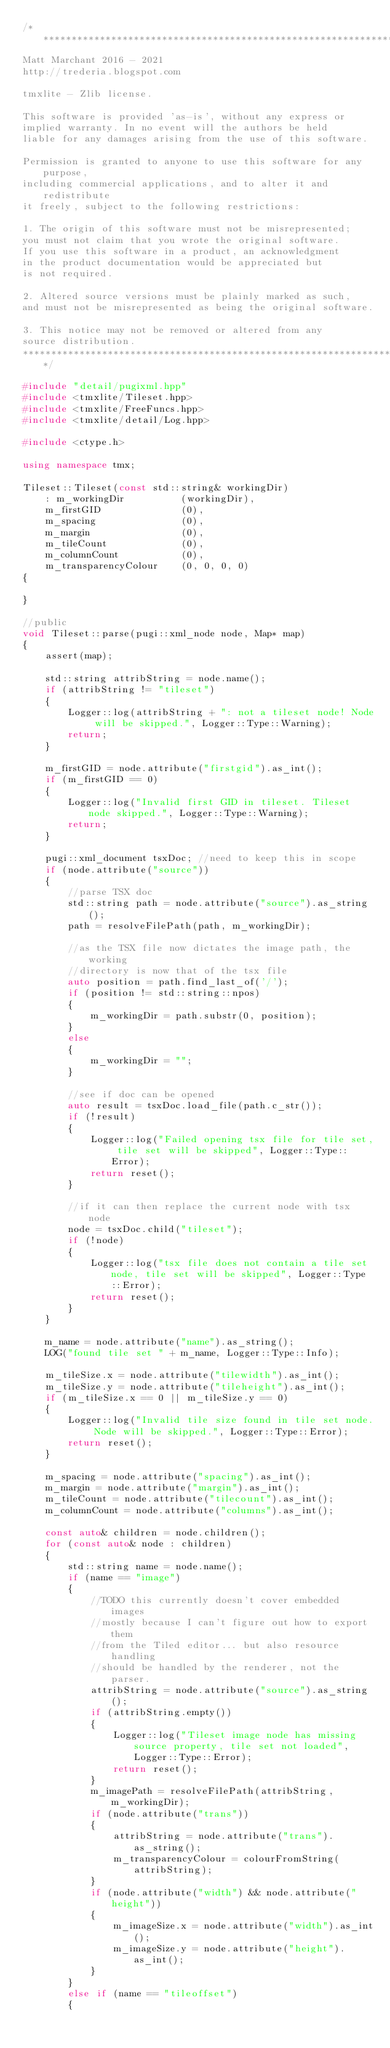Convert code to text. <code><loc_0><loc_0><loc_500><loc_500><_C++_>/*********************************************************************
Matt Marchant 2016 - 2021
http://trederia.blogspot.com

tmxlite - Zlib license.

This software is provided 'as-is', without any express or
implied warranty. In no event will the authors be held
liable for any damages arising from the use of this software.

Permission is granted to anyone to use this software for any purpose,
including commercial applications, and to alter it and redistribute
it freely, subject to the following restrictions:

1. The origin of this software must not be misrepresented;
you must not claim that you wrote the original software.
If you use this software in a product, an acknowledgment
in the product documentation would be appreciated but
is not required.

2. Altered source versions must be plainly marked as such,
and must not be misrepresented as being the original software.

3. This notice may not be removed or altered from any
source distribution.
*********************************************************************/

#include "detail/pugixml.hpp"
#include <tmxlite/Tileset.hpp>
#include <tmxlite/FreeFuncs.hpp>
#include <tmxlite/detail/Log.hpp>

#include <ctype.h>

using namespace tmx;

Tileset::Tileset(const std::string& workingDir)
    : m_workingDir          (workingDir),
    m_firstGID              (0),
    m_spacing               (0),
    m_margin                (0),
    m_tileCount             (0),
    m_columnCount           (0),
    m_transparencyColour    (0, 0, 0, 0)
{

}

//public
void Tileset::parse(pugi::xml_node node, Map* map)
{
    assert(map);

    std::string attribString = node.name();
    if (attribString != "tileset")
    {
        Logger::log(attribString + ": not a tileset node! Node will be skipped.", Logger::Type::Warning);
        return;
    }
    
    m_firstGID = node.attribute("firstgid").as_int();
    if (m_firstGID == 0)
    {
        Logger::log("Invalid first GID in tileset. Tileset node skipped.", Logger::Type::Warning);
        return;
    }

    pugi::xml_document tsxDoc; //need to keep this in scope
    if (node.attribute("source"))
    {
        //parse TSX doc
        std::string path = node.attribute("source").as_string();
        path = resolveFilePath(path, m_workingDir);

        //as the TSX file now dictates the image path, the working
        //directory is now that of the tsx file
        auto position = path.find_last_of('/');
        if (position != std::string::npos)
        {
            m_workingDir = path.substr(0, position);
        }
        else
        {
            m_workingDir = "";
        }

        //see if doc can be opened
        auto result = tsxDoc.load_file(path.c_str());
        if (!result)
        {
            Logger::log("Failed opening tsx file for tile set, tile set will be skipped", Logger::Type::Error);
            return reset();
        }

        //if it can then replace the current node with tsx node
        node = tsxDoc.child("tileset");
        if (!node)
        {
            Logger::log("tsx file does not contain a tile set node, tile set will be skipped", Logger::Type::Error);
            return reset();
        }
    }

    m_name = node.attribute("name").as_string();
    LOG("found tile set " + m_name, Logger::Type::Info);

    m_tileSize.x = node.attribute("tilewidth").as_int();
    m_tileSize.y = node.attribute("tileheight").as_int();
    if (m_tileSize.x == 0 || m_tileSize.y == 0)
    {
        Logger::log("Invalid tile size found in tile set node. Node will be skipped.", Logger::Type::Error);
        return reset();
    }

    m_spacing = node.attribute("spacing").as_int();
    m_margin = node.attribute("margin").as_int();
    m_tileCount = node.attribute("tilecount").as_int();
    m_columnCount = node.attribute("columns").as_int();

    const auto& children = node.children();
    for (const auto& node : children)
    {
        std::string name = node.name();
        if (name == "image")
        {
            //TODO this currently doesn't cover embedded images
            //mostly because I can't figure out how to export them
            //from the Tiled editor... but also resource handling
            //should be handled by the renderer, not the parser.
            attribString = node.attribute("source").as_string();
            if (attribString.empty())
            {
                Logger::log("Tileset image node has missing source property, tile set not loaded", Logger::Type::Error);
                return reset();
            }
            m_imagePath = resolveFilePath(attribString, m_workingDir);
            if (node.attribute("trans"))
            {
                attribString = node.attribute("trans").as_string();
                m_transparencyColour = colourFromString(attribString);
            }
            if (node.attribute("width") && node.attribute("height"))
            {
                m_imageSize.x = node.attribute("width").as_int();
                m_imageSize.y = node.attribute("height").as_int();
            }
        }
        else if (name == "tileoffset")
        {</code> 